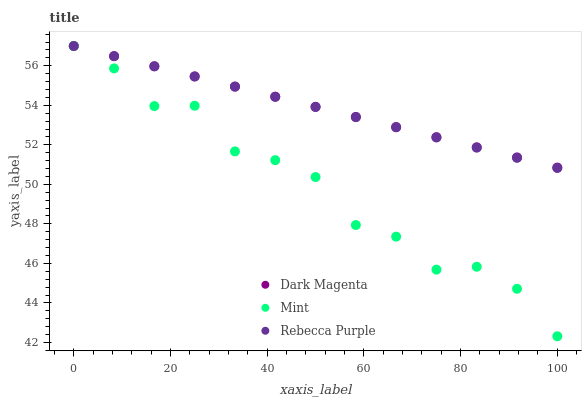Does Mint have the minimum area under the curve?
Answer yes or no. Yes. Does Dark Magenta have the maximum area under the curve?
Answer yes or no. Yes. Does Rebecca Purple have the minimum area under the curve?
Answer yes or no. No. Does Rebecca Purple have the maximum area under the curve?
Answer yes or no. No. Is Dark Magenta the smoothest?
Answer yes or no. Yes. Is Mint the roughest?
Answer yes or no. Yes. Is Rebecca Purple the smoothest?
Answer yes or no. No. Is Rebecca Purple the roughest?
Answer yes or no. No. Does Mint have the lowest value?
Answer yes or no. Yes. Does Rebecca Purple have the lowest value?
Answer yes or no. No. Does Rebecca Purple have the highest value?
Answer yes or no. Yes. Does Rebecca Purple intersect Dark Magenta?
Answer yes or no. Yes. Is Rebecca Purple less than Dark Magenta?
Answer yes or no. No. Is Rebecca Purple greater than Dark Magenta?
Answer yes or no. No. 